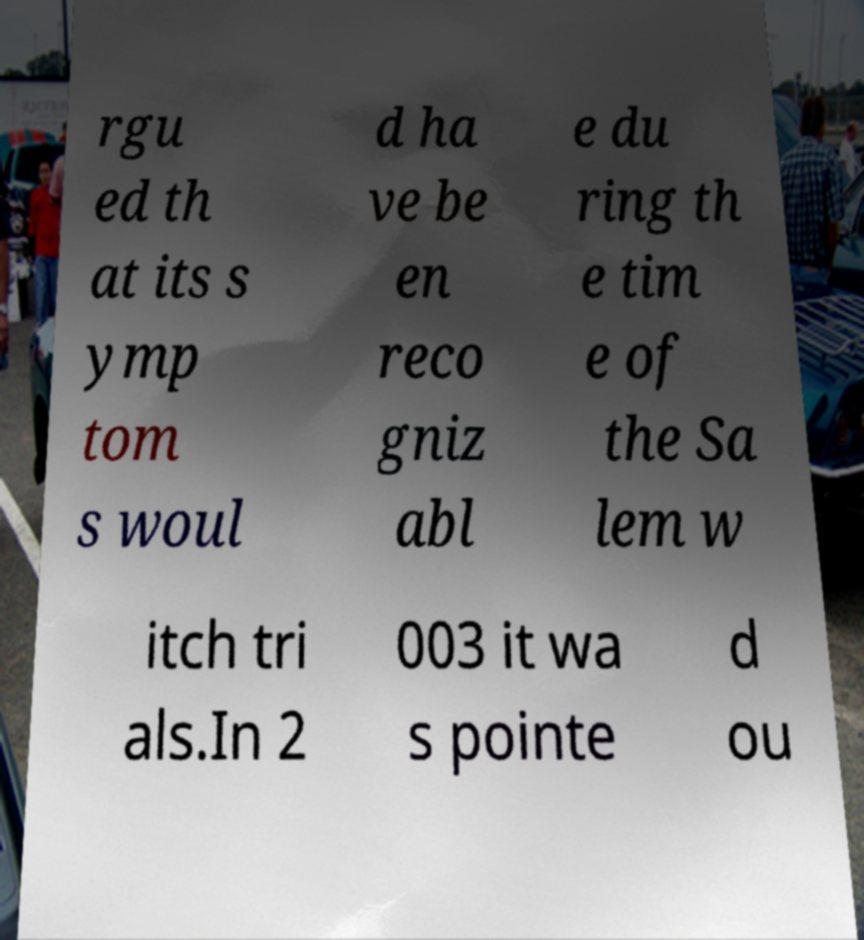Could you assist in decoding the text presented in this image and type it out clearly? rgu ed th at its s ymp tom s woul d ha ve be en reco gniz abl e du ring th e tim e of the Sa lem w itch tri als.In 2 003 it wa s pointe d ou 